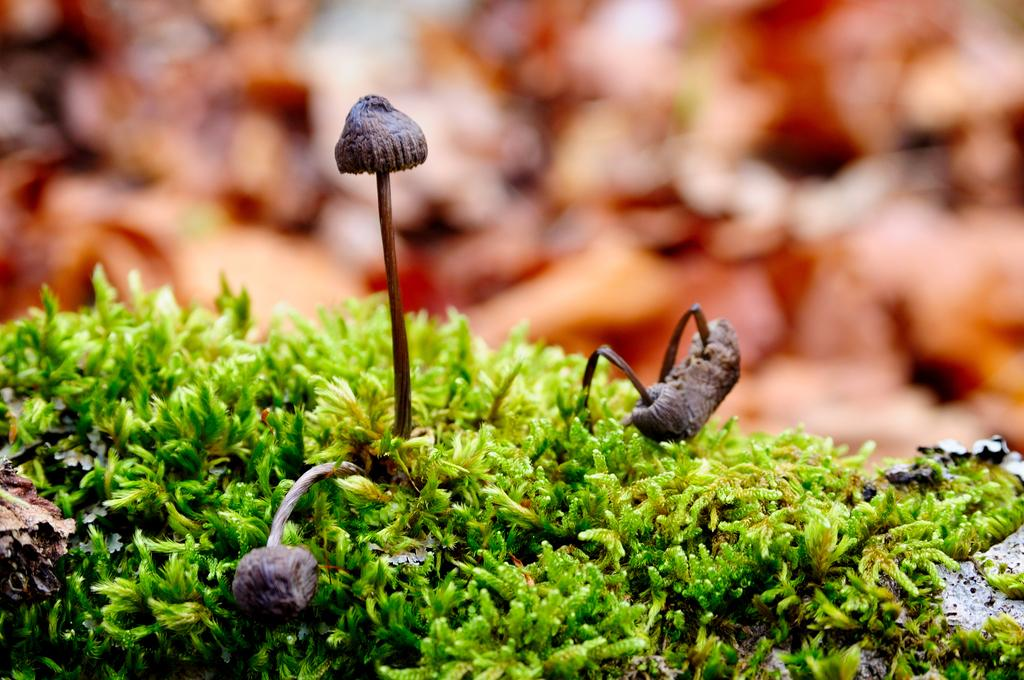What type of vegetation can be seen in the image? There are mushrooms and grass in the image. Can you describe the background of the image? The background of the image is blurred. What type of behavior does the sofa exhibit in the image? There is no sofa present in the image, so it cannot exhibit any behavior. 